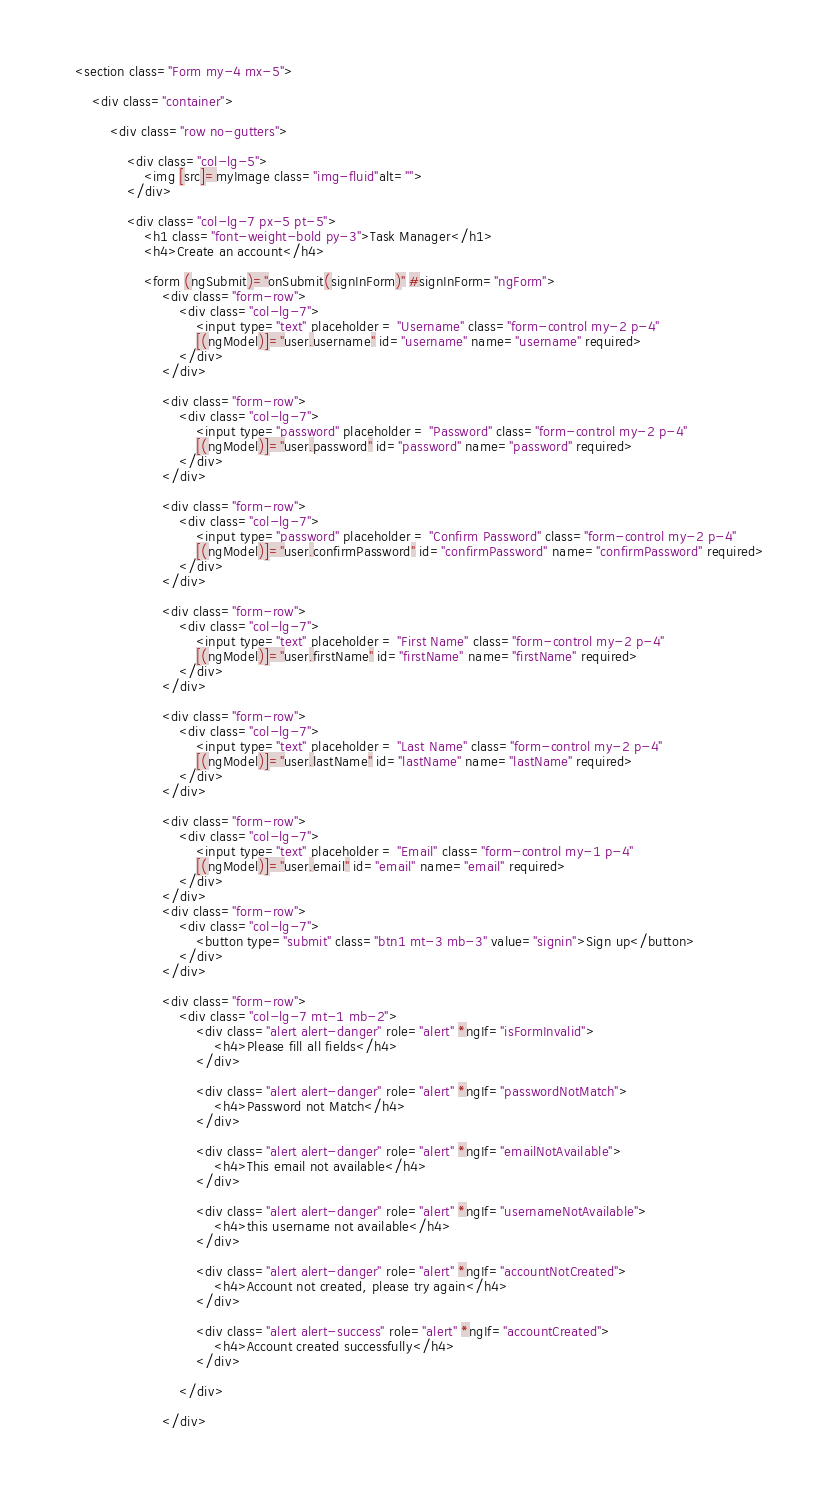<code> <loc_0><loc_0><loc_500><loc_500><_HTML_><section class="Form my-4 mx-5">

    <div class="container">

        <div class="row no-gutters">

            <div class="col-lg-5">
                <img [src]=myImage class="img-fluid"alt="">
            </div>

            <div class="col-lg-7 px-5 pt-5">
                <h1 class="font-weight-bold py-3">Task Manager</h1>
                <h4>Create an account</h4>
                
                <form (ngSubmit)="onSubmit(signInForm)" #signInForm="ngForm">
                    <div class="form-row">
                        <div class="col-lg-7">
                            <input type="text" placeholder = "Username" class="form-control my-2 p-4" 
                            [(ngModel)]="user.username" id="username" name="username" required>
                        </div>
                    </div>

                    <div class="form-row">
                        <div class="col-lg-7">
                            <input type="password" placeholder = "Password" class="form-control my-2 p-4" 
                            [(ngModel)]="user.password" id="password" name="password" required>
                        </div>         
                    </div>

                    <div class="form-row">
                        <div class="col-lg-7">
                            <input type="password" placeholder = "Confirm Password" class="form-control my-2 p-4" 
                            [(ngModel)]="user.confirmPassword" id="confirmPassword" name="confirmPassword" required>
                        </div>
                    </div>

                    <div class="form-row">
                        <div class="col-lg-7">
                            <input type="text" placeholder = "First Name" class="form-control my-2 p-4" 
                            [(ngModel)]="user.firstName" id="firstName" name="firstName" required>
                        </div>
                    </div>

                    <div class="form-row">
                        <div class="col-lg-7">
                            <input type="text" placeholder = "Last Name" class="form-control my-2 p-4" 
                            [(ngModel)]="user.lastName" id="lastName" name="lastName" required>
                        </div>
                    </div>

                    <div class="form-row">
                        <div class="col-lg-7">
                            <input type="text" placeholder = "Email" class="form-control my-1 p-4" 
                            [(ngModel)]="user.email" id="email" name="email" required>
                        </div>
                    </div>
                    <div class="form-row">
                        <div class="col-lg-7">
                            <button type="submit" class="btn1 mt-3 mb-3" value="signin">Sign up</button>
                        </div>
                    </div>

                    <div class="form-row">
                        <div class="col-lg-7 mt-1 mb-2">
                            <div class="alert alert-danger" role="alert" *ngIf="isFormInvalid">
                                <h4>Please fill all fields</h4>
                            </div>        
                            
                            <div class="alert alert-danger" role="alert" *ngIf="passwordNotMatch">
                                <h4>Password not Match</h4>
                            </div>   
                            
                            <div class="alert alert-danger" role="alert" *ngIf="emailNotAvailable">
                                <h4>This email not available</h4>
                            </div>        
                            
                            <div class="alert alert-danger" role="alert" *ngIf="usernameNotAvailable">
                                <h4>this username not available</h4>
                            </div>  

                            <div class="alert alert-danger" role="alert" *ngIf="accountNotCreated">
                                <h4>Account not created, please try again</h4>
                            </div>  

                            <div class="alert alert-success" role="alert" *ngIf="accountCreated">
                                <h4>Account created successfully</h4>
                            </div>  
                            
                        </div>

                    </div>
</code> 